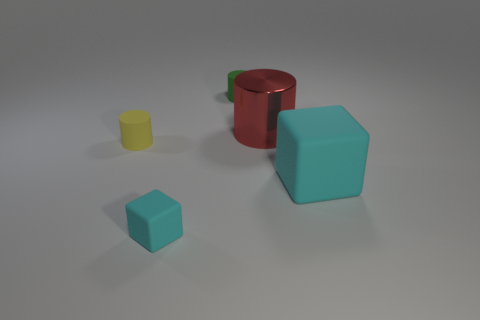The red metal cylinder has what size?
Provide a succinct answer. Large. What number of rubber cylinders are the same size as the green object?
Make the answer very short. 1. There is a tiny yellow thing that is the same shape as the big red metal thing; what is it made of?
Provide a succinct answer. Rubber. What is the shape of the matte object that is in front of the tiny yellow rubber cylinder and left of the big red thing?
Ensure brevity in your answer.  Cube. What shape is the big thing that is on the left side of the big cyan block?
Give a very brief answer. Cylinder. What number of things are both in front of the small green cylinder and on the left side of the large cyan rubber thing?
Make the answer very short. 3. There is a yellow object; is its size the same as the rubber block right of the big red metal cylinder?
Provide a short and direct response. No. There is a red shiny object right of the small object to the left of the matte cube that is on the left side of the big cube; how big is it?
Your answer should be very brief. Large. There is a rubber block that is in front of the big cyan object; what is its size?
Your response must be concise. Small. There is a small yellow object that is made of the same material as the green cylinder; what shape is it?
Give a very brief answer. Cylinder. 